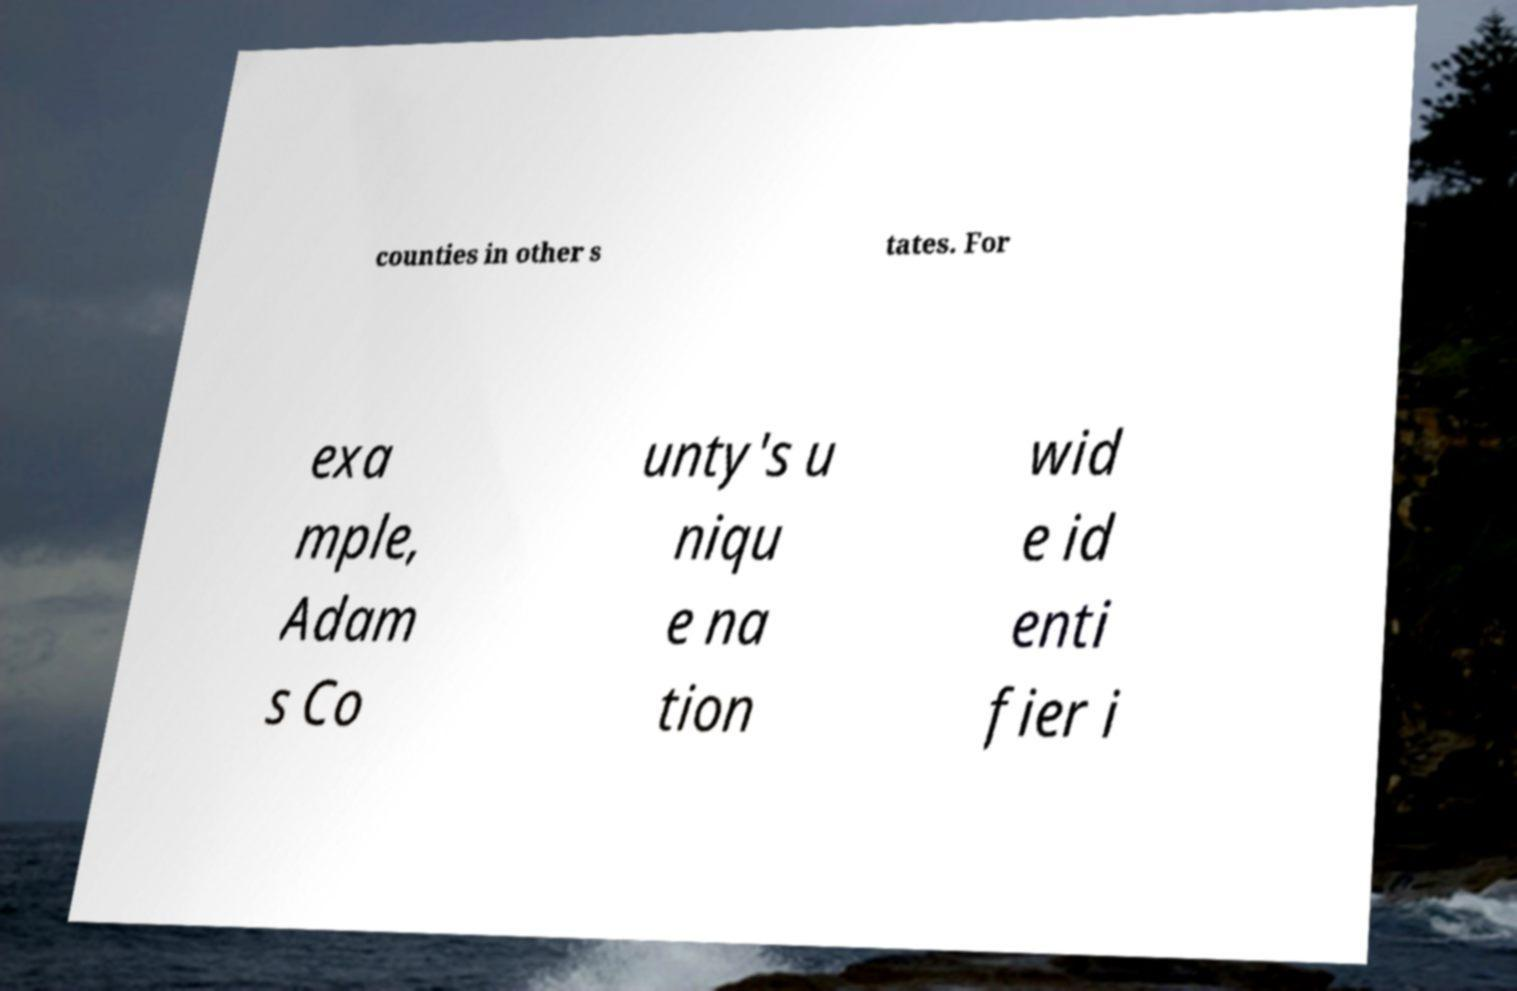What messages or text are displayed in this image? I need them in a readable, typed format. counties in other s tates. For exa mple, Adam s Co unty's u niqu e na tion wid e id enti fier i 